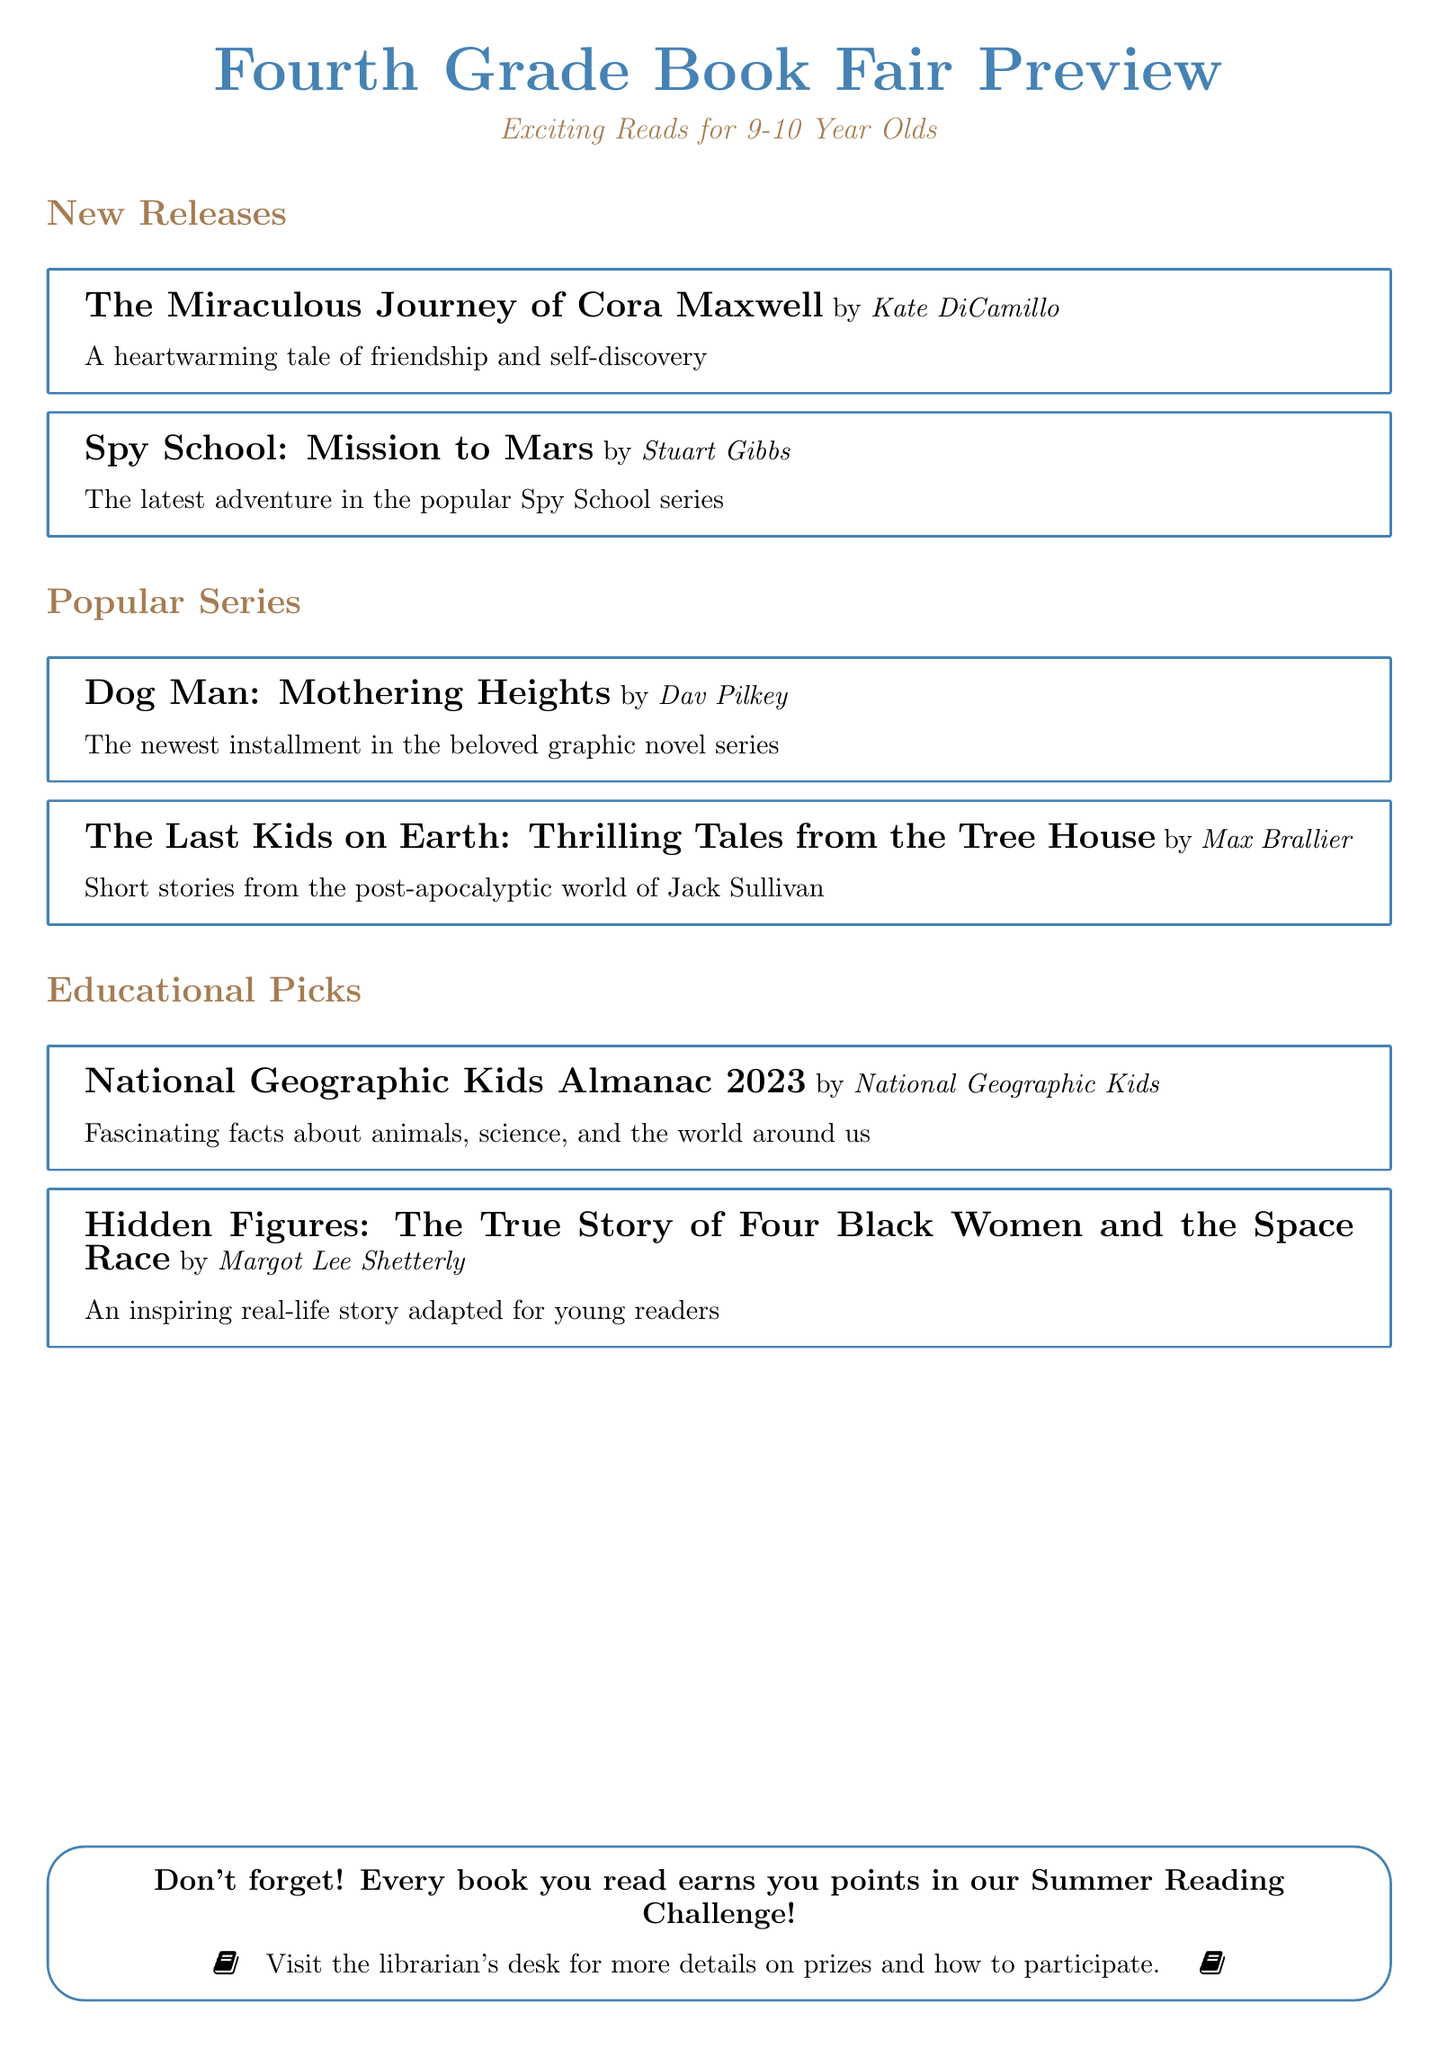What is the title of the new release by Kate DiCamillo? The title is directly mentioned in the New Releases section of the document.
Answer: The Miraculous Journey of Cora Maxwell Who is the author of "Spy School: Mission to Mars"? The document lists the author of this book in the New Releases section.
Answer: Stuart Gibbs What is the newest installment in the Dog Man series? The document specifies the latest title in the Popular Series section.
Answer: Dog Man: Mothering Heights How many educational picks are listed in the catalog? The document contains a clear enumeration of educational picks.
Answer: 2 What is the name of the almanac featured in Educational Picks? The title is clearly stated in the Educational Picks section of the document.
Answer: National Geographic Kids Almanac 2023 What genre does "Hidden Figures" fall under in the catalog? The catalog categorizes this book in the Educational Picks section.
Answer: Educational What reminder is included at the end of the document? The document emphasizes a key point related to the reading challenge at the conclusion.
Answer: Every book you read earns you points in our Summer Reading Challenge How many books are featured in the Popular Series section? The document lists books in this specific section to reach the answer.
Answer: 2 What is the theme of "The Miraculous Journey of Cora Maxwell"? The document provides a brief description that indicates the theme.
Answer: Friendship and self-discovery 